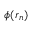<formula> <loc_0><loc_0><loc_500><loc_500>\phi ( r _ { n } )</formula> 